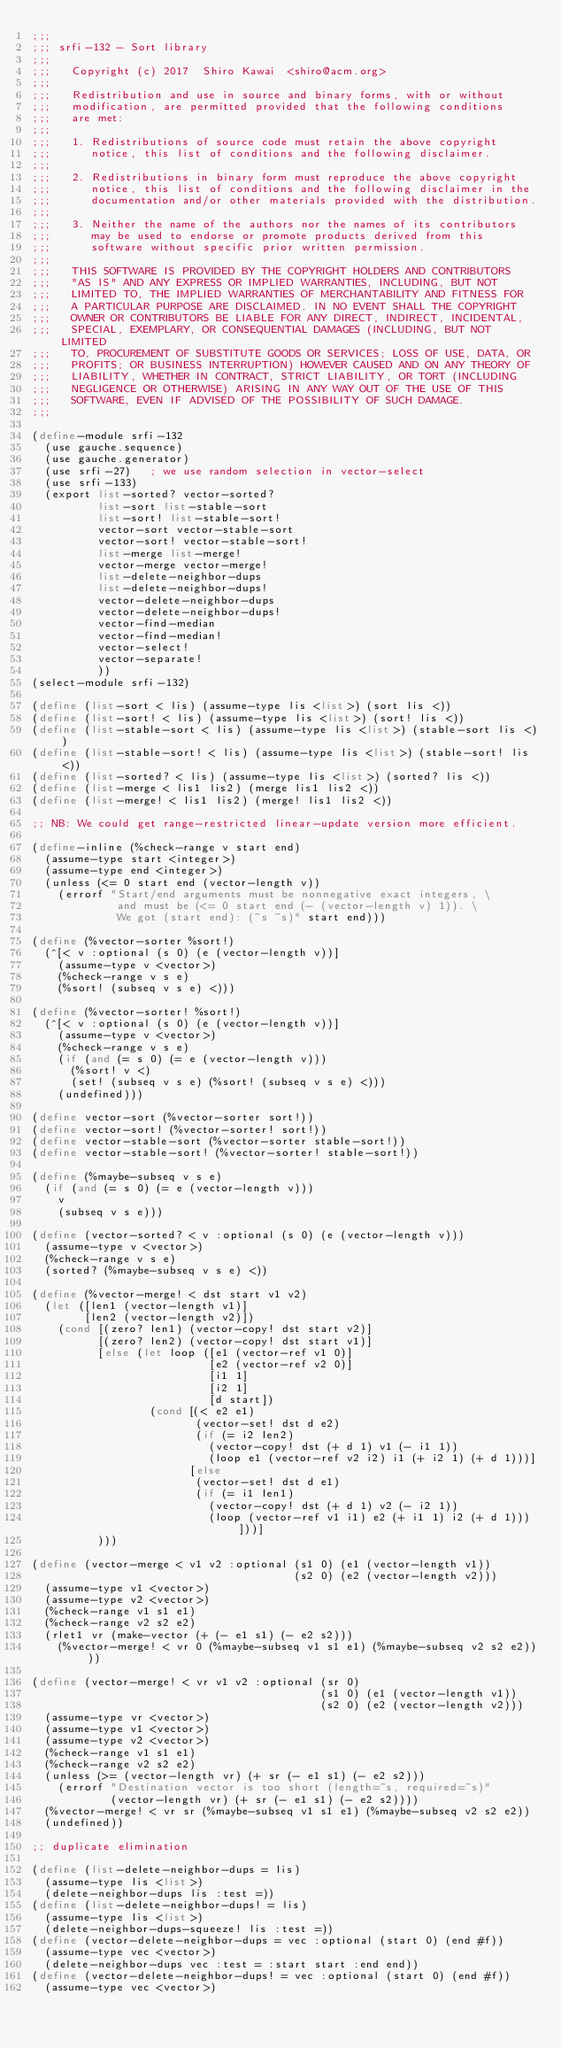Convert code to text. <code><loc_0><loc_0><loc_500><loc_500><_Scheme_>;;;
;;; srfi-132 - Sort library
;;;
;;;   Copyright (c) 2017  Shiro Kawai  <shiro@acm.org>
;;;
;;;   Redistribution and use in source and binary forms, with or without
;;;   modification, are permitted provided that the following conditions
;;;   are met:
;;;
;;;   1. Redistributions of source code must retain the above copyright
;;;      notice, this list of conditions and the following disclaimer.
;;;
;;;   2. Redistributions in binary form must reproduce the above copyright
;;;      notice, this list of conditions and the following disclaimer in the
;;;      documentation and/or other materials provided with the distribution.
;;;
;;;   3. Neither the name of the authors nor the names of its contributors
;;;      may be used to endorse or promote products derived from this
;;;      software without specific prior written permission.
;;;
;;;   THIS SOFTWARE IS PROVIDED BY THE COPYRIGHT HOLDERS AND CONTRIBUTORS
;;;   "AS IS" AND ANY EXPRESS OR IMPLIED WARRANTIES, INCLUDING, BUT NOT
;;;   LIMITED TO, THE IMPLIED WARRANTIES OF MERCHANTABILITY AND FITNESS FOR
;;;   A PARTICULAR PURPOSE ARE DISCLAIMED. IN NO EVENT SHALL THE COPYRIGHT
;;;   OWNER OR CONTRIBUTORS BE LIABLE FOR ANY DIRECT, INDIRECT, INCIDENTAL,
;;;   SPECIAL, EXEMPLARY, OR CONSEQUENTIAL DAMAGES (INCLUDING, BUT NOT LIMITED
;;;   TO, PROCUREMENT OF SUBSTITUTE GOODS OR SERVICES; LOSS OF USE, DATA, OR
;;;   PROFITS; OR BUSINESS INTERRUPTION) HOWEVER CAUSED AND ON ANY THEORY OF
;;;   LIABILITY, WHETHER IN CONTRACT, STRICT LIABILITY, OR TORT (INCLUDING
;;;   NEGLIGENCE OR OTHERWISE) ARISING IN ANY WAY OUT OF THE USE OF THIS
;;;   SOFTWARE, EVEN IF ADVISED OF THE POSSIBILITY OF SUCH DAMAGE.
;;;

(define-module srfi-132
  (use gauche.sequence)
  (use gauche.generator)
  (use srfi-27)   ; we use random selection in vector-select
  (use srfi-133)
  (export list-sorted? vector-sorted?
          list-sort list-stable-sort
          list-sort! list-stable-sort!
          vector-sort vector-stable-sort
          vector-sort! vector-stable-sort!
          list-merge list-merge!
          vector-merge vector-merge!
          list-delete-neighbor-dups
          list-delete-neighbor-dups!
          vector-delete-neighbor-dups
          vector-delete-neighbor-dups!
          vector-find-median
          vector-find-median!
          vector-select!
          vector-separate!
          ))
(select-module srfi-132)

(define (list-sort < lis) (assume-type lis <list>) (sort lis <))
(define (list-sort! < lis) (assume-type lis <list>) (sort! lis <))
(define (list-stable-sort < lis) (assume-type lis <list>) (stable-sort lis <))
(define (list-stable-sort! < lis) (assume-type lis <list>) (stable-sort! lis <))
(define (list-sorted? < lis) (assume-type lis <list>) (sorted? lis <))
(define (list-merge < lis1 lis2) (merge lis1 lis2 <))
(define (list-merge! < lis1 lis2) (merge! lis1 lis2 <))

;; NB: We could get range-restricted linear-update version more efficient.

(define-inline (%check-range v start end)
  (assume-type start <integer>)
  (assume-type end <integer>)
  (unless (<= 0 start end (vector-length v))
    (errorf "Start/end arguments must be nonnegative exact integers, \
             and must be (<= 0 start end (- (vector-length v) 1)). \
             We got (start end): (~s ~s)" start end)))

(define (%vector-sorter %sort!)
  (^[< v :optional (s 0) (e (vector-length v))]
    (assume-type v <vector>)
    (%check-range v s e)
    (%sort! (subseq v s e) <)))

(define (%vector-sorter! %sort!)
  (^[< v :optional (s 0) (e (vector-length v))]
    (assume-type v <vector>)
    (%check-range v s e)
    (if (and (= s 0) (= e (vector-length v)))
      (%sort! v <)
      (set! (subseq v s e) (%sort! (subseq v s e) <)))
    (undefined)))

(define vector-sort (%vector-sorter sort!))
(define vector-sort! (%vector-sorter! sort!))
(define vector-stable-sort (%vector-sorter stable-sort!))
(define vector-stable-sort! (%vector-sorter! stable-sort!))

(define (%maybe-subseq v s e)
  (if (and (= s 0) (= e (vector-length v)))
    v
    (subseq v s e)))

(define (vector-sorted? < v :optional (s 0) (e (vector-length v)))
  (assume-type v <vector>)
  (%check-range v s e)
  (sorted? (%maybe-subseq v s e) <))

(define (%vector-merge! < dst start v1 v2)
  (let ([len1 (vector-length v1)]
        [len2 (vector-length v2)])
    (cond [(zero? len1) (vector-copy! dst start v2)]
          [(zero? len2) (vector-copy! dst start v1)]
          [else (let loop ([e1 (vector-ref v1 0)]
                           [e2 (vector-ref v2 0)]
                           [i1 1]
                           [i2 1]
                           [d start])
                  (cond [(< e2 e1)
                         (vector-set! dst d e2)
                         (if (= i2 len2)
                           (vector-copy! dst (+ d 1) v1 (- i1 1))
                           (loop e1 (vector-ref v2 i2) i1 (+ i2 1) (+ d 1)))]
                        [else
                         (vector-set! dst d e1)
                         (if (= i1 len1)
                           (vector-copy! dst (+ d 1) v2 (- i2 1))
                           (loop (vector-ref v1 i1) e2 (+ i1 1) i2 (+ d 1)))]))]
          )))

(define (vector-merge < v1 v2 :optional (s1 0) (e1 (vector-length v1))
                                        (s2 0) (e2 (vector-length v2)))
  (assume-type v1 <vector>)
  (assume-type v2 <vector>)
  (%check-range v1 s1 e1)
  (%check-range v2 s2 e2)
  (rlet1 vr (make-vector (+ (- e1 s1) (- e2 s2)))
    (%vector-merge! < vr 0 (%maybe-subseq v1 s1 e1) (%maybe-subseq v2 s2 e2))))

(define (vector-merge! < vr v1 v2 :optional (sr 0)
                                            (s1 0) (e1 (vector-length v1))
                                            (s2 0) (e2 (vector-length v2)))
  (assume-type vr <vector>)
  (assume-type v1 <vector>)
  (assume-type v2 <vector>)
  (%check-range v1 s1 e1)
  (%check-range v2 s2 e2)
  (unless (>= (vector-length vr) (+ sr (- e1 s1) (- e2 s2)))
    (errorf "Destination vector is too short (length=~s, required=~s)"
            (vector-length vr) (+ sr (- e1 s1) (- e2 s2))))
  (%vector-merge! < vr sr (%maybe-subseq v1 s1 e1) (%maybe-subseq v2 s2 e2))
  (undefined))

;; duplicate elimination

(define (list-delete-neighbor-dups = lis)
  (assume-type lis <list>)
  (delete-neighbor-dups lis :test =))
(define (list-delete-neighbor-dups! = lis)
  (assume-type lis <list>)
  (delete-neighbor-dups-squeeze! lis :test =))
(define (vector-delete-neighbor-dups = vec :optional (start 0) (end #f))
  (assume-type vec <vector>)
  (delete-neighbor-dups vec :test = :start start :end end))
(define (vector-delete-neighbor-dups! = vec :optional (start 0) (end #f))
  (assume-type vec <vector>)</code> 